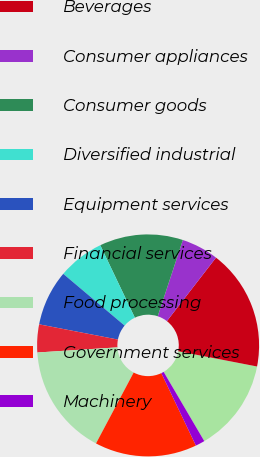Convert chart to OTSL. <chart><loc_0><loc_0><loc_500><loc_500><pie_chart><fcel>Aerospace<fcel>Beverages<fcel>Consumer appliances<fcel>Consumer goods<fcel>Diversified industrial<fcel>Equipment services<fcel>Financial services<fcel>Food processing<fcel>Government services<fcel>Machinery<nl><fcel>13.51%<fcel>17.56%<fcel>5.41%<fcel>12.16%<fcel>6.76%<fcel>8.11%<fcel>4.06%<fcel>16.21%<fcel>14.86%<fcel>1.36%<nl></chart> 